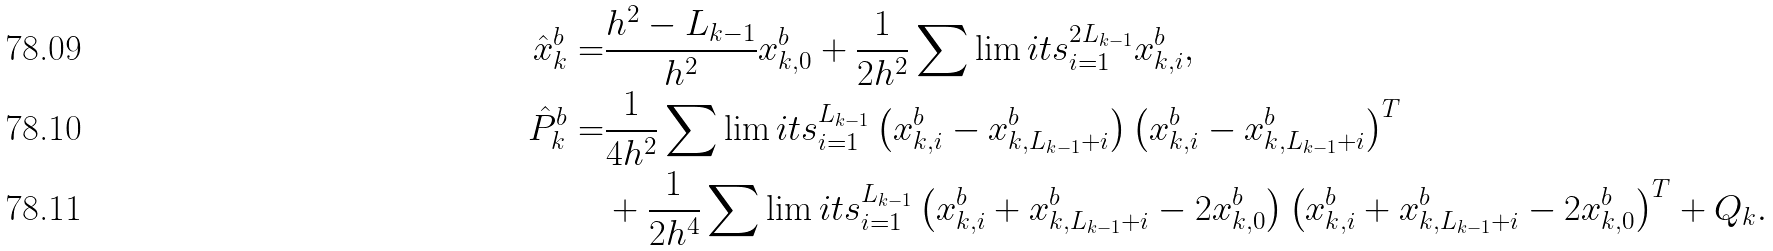Convert formula to latex. <formula><loc_0><loc_0><loc_500><loc_500>\hat { x } _ { k } ^ { b } = & \frac { h ^ { 2 } - L _ { k - 1 } } { h ^ { 2 } } x _ { k , 0 } ^ { b } + \frac { 1 } { 2 h ^ { 2 } } \sum \lim i t s _ { i = 1 } ^ { 2 L _ { k - 1 } } x _ { k , i } ^ { b } , \\ \hat { P } _ { k } ^ { b } = & \frac { 1 } { 4 h ^ { 2 } } \sum \lim i t s _ { i = 1 } ^ { L _ { k - 1 } } \left ( x _ { k , i } ^ { b } - x _ { k , L _ { k - 1 } + i } ^ { b } \right ) \left ( x _ { k , i } ^ { b } - x _ { k , L _ { k - 1 } + i } ^ { b } \right ) ^ { T } \\ & + \frac { 1 } { 2 h ^ { 4 } } \sum \lim i t s _ { i = 1 } ^ { L _ { k - 1 } } \left ( x _ { k , i } ^ { b } + x _ { k , L _ { k - 1 } + i } ^ { b } - 2 x _ { k , 0 } ^ { b } \right ) \left ( x _ { k , i } ^ { b } + x _ { k , L _ { k - 1 } + i } ^ { b } - 2 x _ { k , 0 } ^ { b } \right ) ^ { T } + Q _ { k } .</formula> 